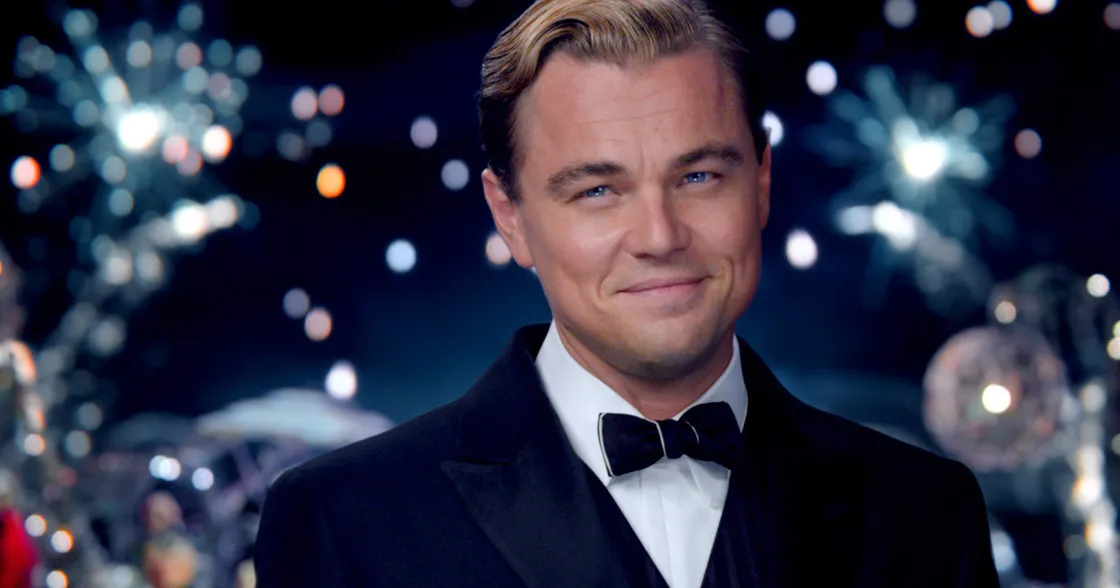Can you describe the main features of this image for me? The image showcases a well-dressed gentleman, standing confidently in front of a vibrant backdrop filled with festive elements such as fireworks and dazzling lights. His attire consists of a classic black tuxedo, paired with a white shirt and a black bow tie, giving him an air of elegance and sophistication. The joyful atmosphere is accentuated by his slight, charismatic smile directed towards the camera, which draws the viewer's attention to his poised and charming demeanor. 